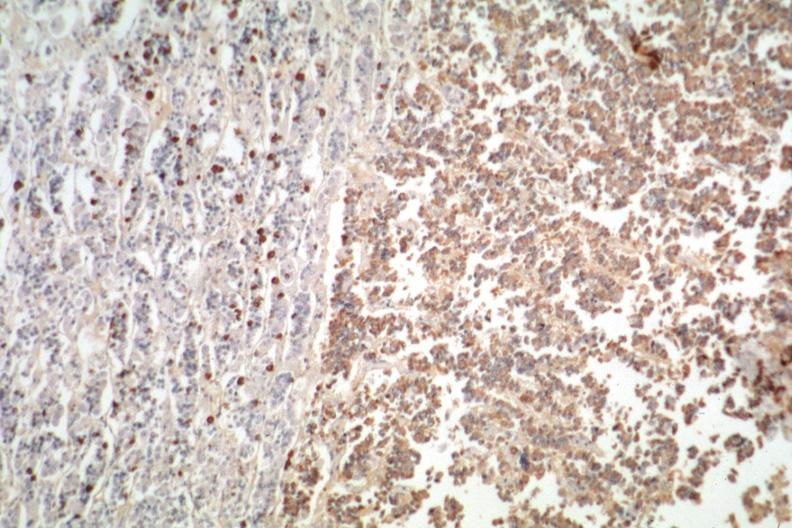s acid present?
Answer the question using a single word or phrase. No 